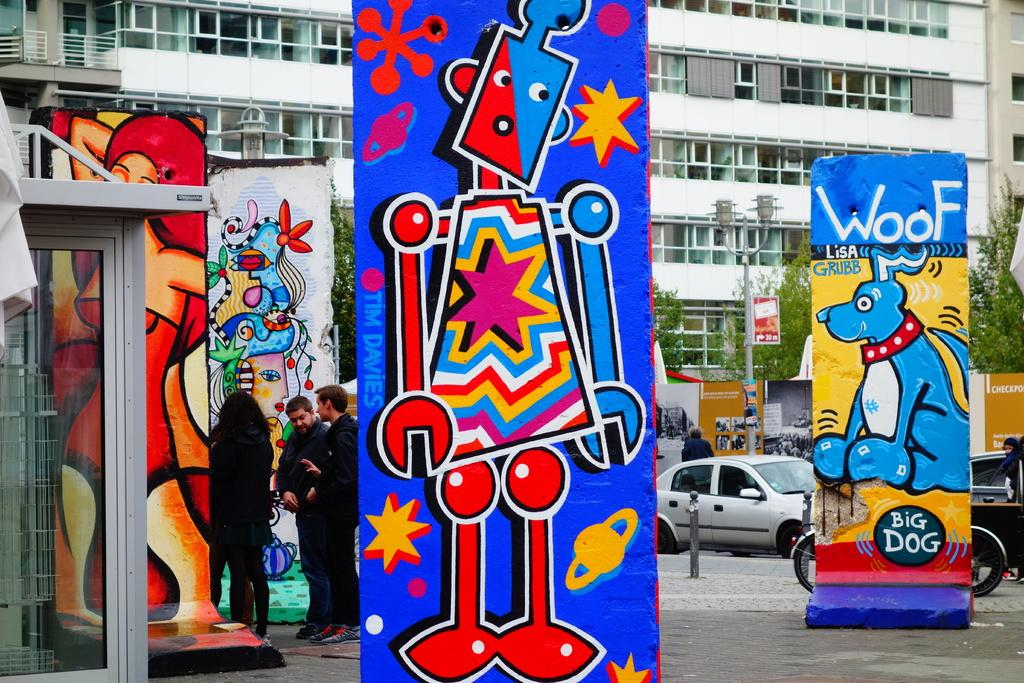<image>
Give a short and clear explanation of the subsequent image. a dog looking sign that says woof on it 